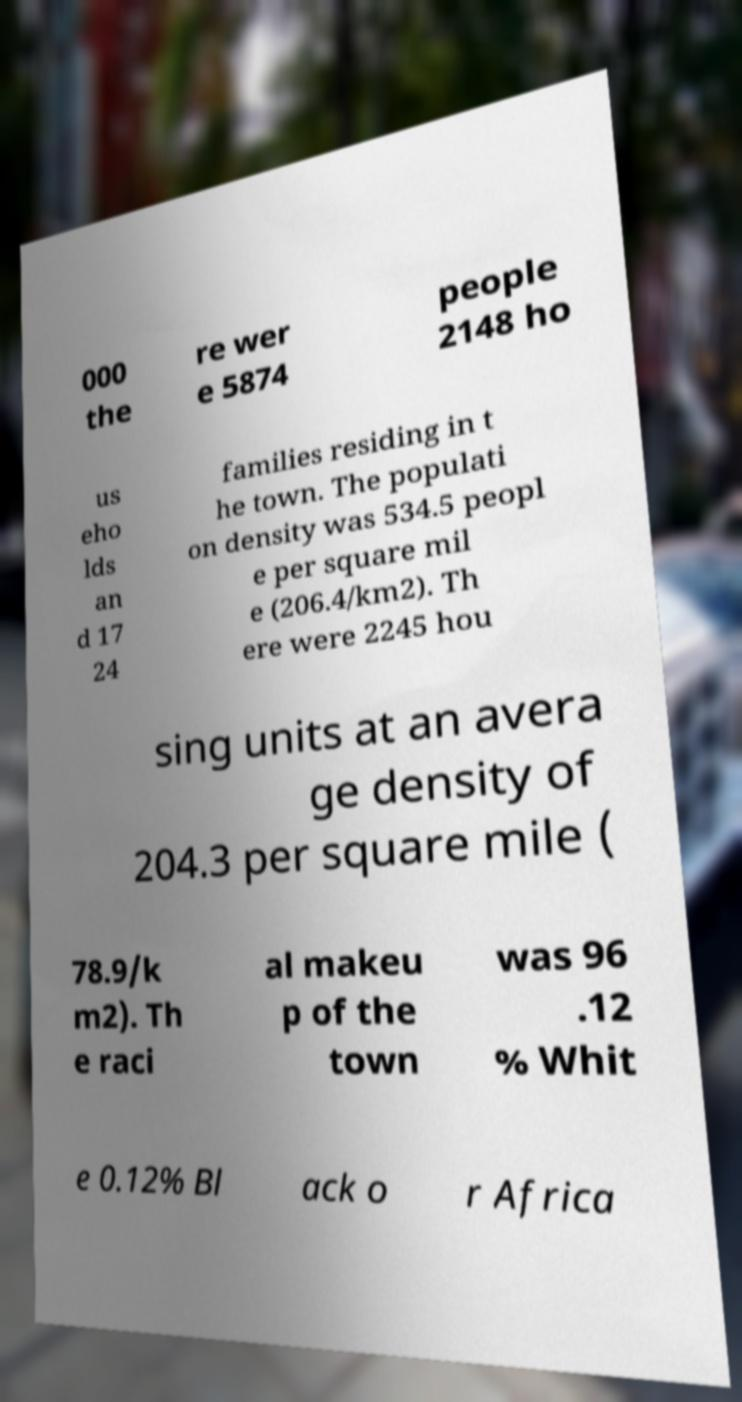For documentation purposes, I need the text within this image transcribed. Could you provide that? 000 the re wer e 5874 people 2148 ho us eho lds an d 17 24 families residing in t he town. The populati on density was 534.5 peopl e per square mil e (206.4/km2). Th ere were 2245 hou sing units at an avera ge density of 204.3 per square mile ( 78.9/k m2). Th e raci al makeu p of the town was 96 .12 % Whit e 0.12% Bl ack o r Africa 